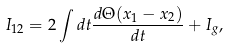Convert formula to latex. <formula><loc_0><loc_0><loc_500><loc_500>I _ { 1 2 } = 2 \int d t \frac { d \Theta ( x _ { 1 } - x _ { 2 } ) } { d t } + I _ { g } ,</formula> 